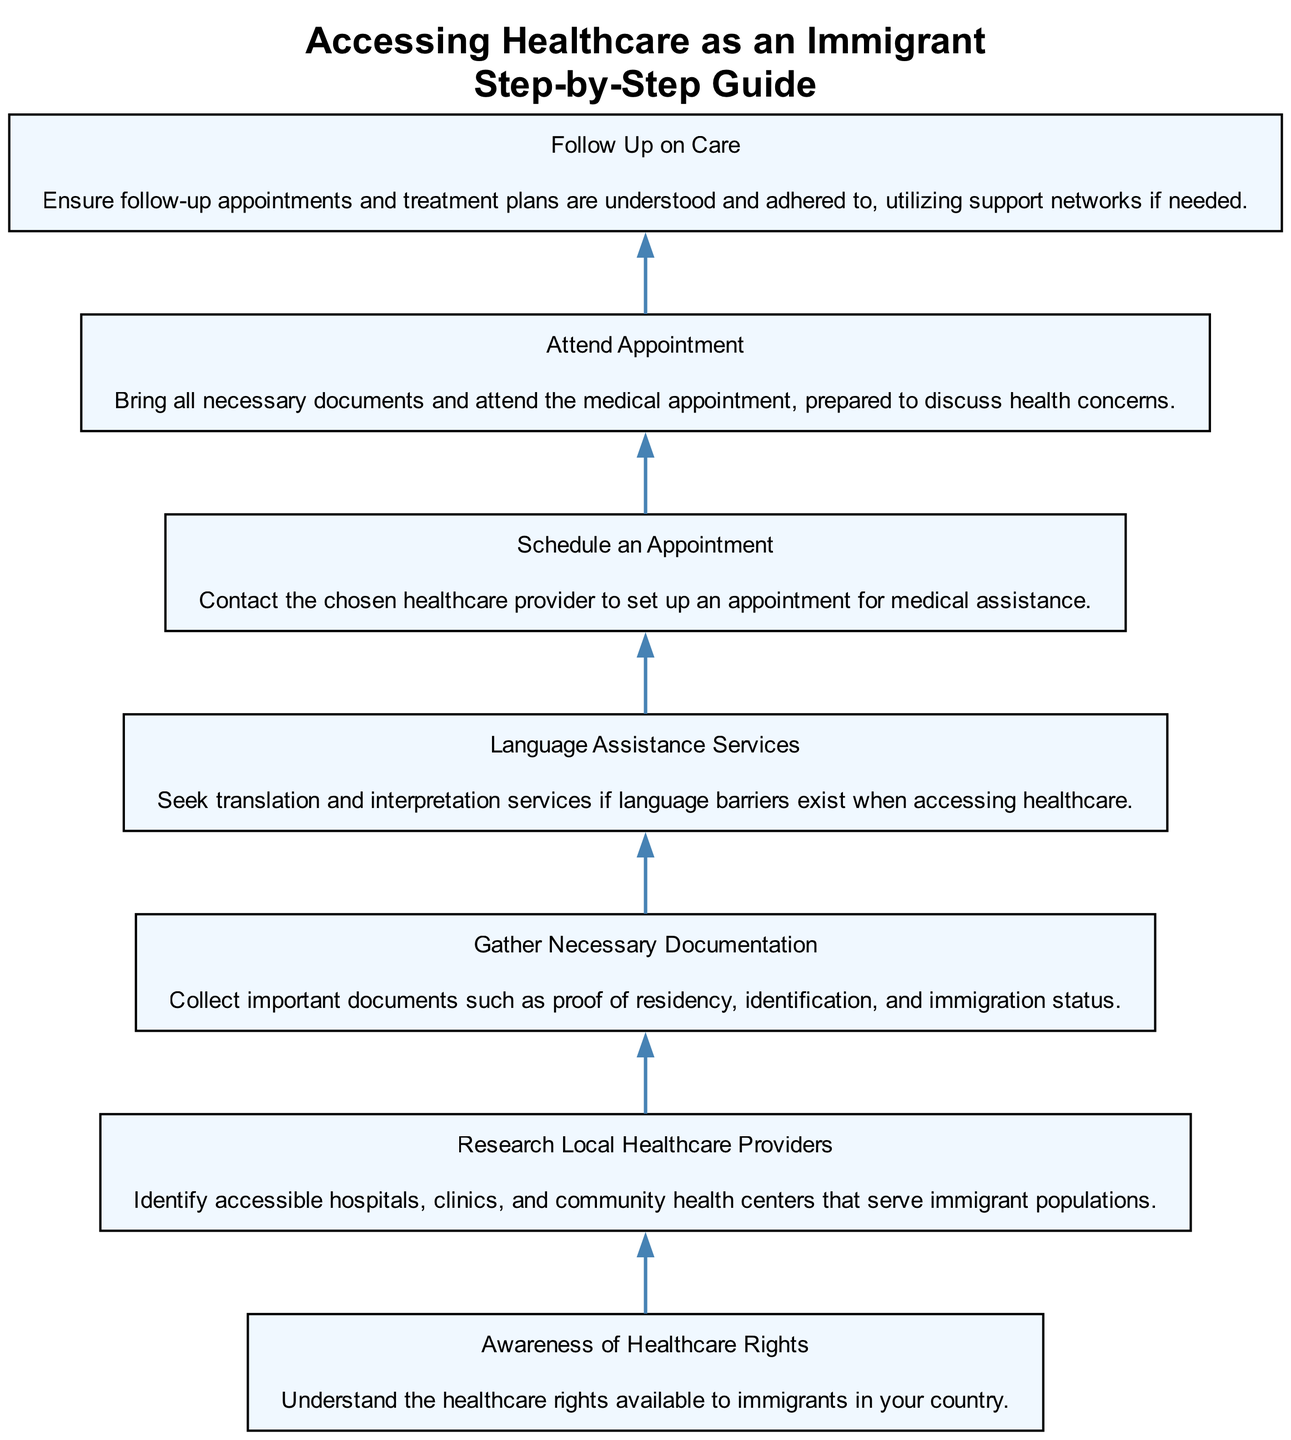What is the first step in accessing healthcare? The first step is marked at the bottom of the diagram, which shows "Awareness of Healthcare Rights" as the starting point for accessing healthcare.
Answer: Awareness of Healthcare Rights How many total steps are there in the diagram? By counting each step represented in the diagram, we find that there are seven distinct steps listed.
Answer: 7 What step comes after "Gather Necessary Documentation"? By following the directional flow of the chart, the step that follows "Gather Necessary Documentation" is "Language Assistance Services," indicating that language support is needed next.
Answer: Language Assistance Services In the flow, which node connects directly to "Attend Appointment"? The "Schedule an Appointment" node directly connects to "Attend Appointment," indicating that scheduling is essential before attending the actual appointment.
Answer: Schedule an Appointment What is required for the last step in the process? The last step, "Follow Up on Care," requires ensuring follow-up appointments and treatment plans are understood, indicating ongoing attention to healthcare needs.
Answer: Follow-up on care How does "Language Assistance Services" impact the flow? "Language Assistance Services" is a crucial step that assists immigrants in overcoming language barriers, thus facilitating a smoother experience accessing healthcare.
Answer: Facilitates communication What is the relationship between "Research Local Healthcare Providers" and "Gather Necessary Documentation"? The diagram shows that "Research Local Healthcare Providers" must be completed prior to "Gather Necessary Documentation," indicating that knowing where to go precedes preparing the necessary documents.
Answer: Sequential step What is the focus of the entire diagram? The diagram focuses on outlining the steps necessary for immigrants to access healthcare services systematically, ensuring they are informed of their rights and available resources.
Answer: Accessing healthcare for immigrants 